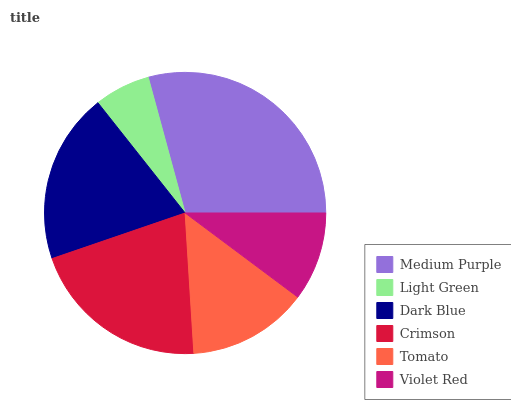Is Light Green the minimum?
Answer yes or no. Yes. Is Medium Purple the maximum?
Answer yes or no. Yes. Is Dark Blue the minimum?
Answer yes or no. No. Is Dark Blue the maximum?
Answer yes or no. No. Is Dark Blue greater than Light Green?
Answer yes or no. Yes. Is Light Green less than Dark Blue?
Answer yes or no. Yes. Is Light Green greater than Dark Blue?
Answer yes or no. No. Is Dark Blue less than Light Green?
Answer yes or no. No. Is Dark Blue the high median?
Answer yes or no. Yes. Is Tomato the low median?
Answer yes or no. Yes. Is Tomato the high median?
Answer yes or no. No. Is Dark Blue the low median?
Answer yes or no. No. 